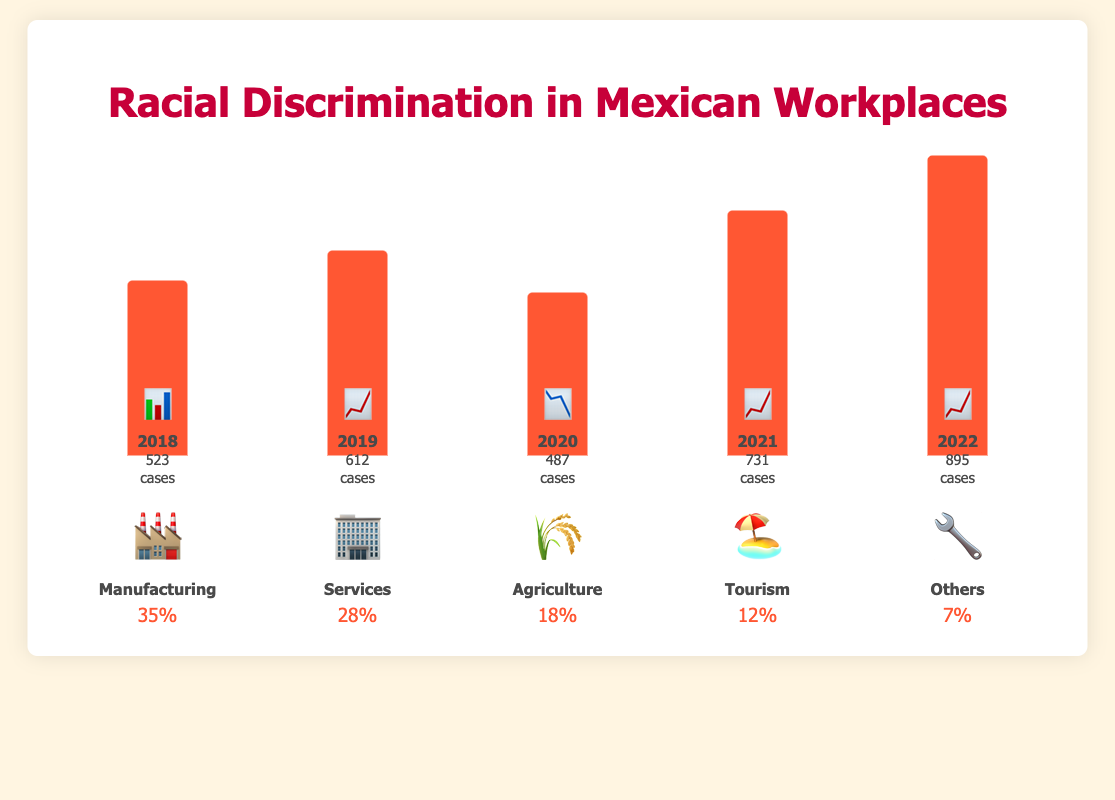How many cases of racial discrimination were reported in Mexican workplaces in 2020? The bar for 2020 shows "487 cases" as per the figure.
Answer: 487 Which year had the highest number of reported cases of racial discrimination? The bar with the greatest height is for the year 2022, marked with "895 cases."
Answer: 2022 What percentage of reported cases come from the Agriculture sector? The Agriculture sector is represented by the emoji 🌾 and has a percentage of "18%" as per the sectors section.
Answer: 18% Compare the number of cases in 2018 to 2019. Did the cases increase or decrease? In 2018, there were 523 cases, and in 2019, there were 612 cases. Since 612 > 523, the cases increased.
Answer: Increased What is the combined percentage of reported cases in the Manufacturing and Services sectors? The percentage for Manufacturing is 35% and for Services, it is 28%. Therefore, 35% + 28% = 63%.
Answer: 63% Which sector has the lowest percentage of reported cases? The "Others" sector, represented by the emoji 🔧, has the smallest percentage of 7%.
Answer: Others By how many cases did reported discrimination increase from 2021 to 2022? The figure shows 731 cases in 2021 and 895 cases in 2022. The difference is 895 - 731 = 164.
Answer: 164 Rank the years from the lowest to the highest reported cases of racial discrimination. The numbers for each year in ascending order are 2020 (487), 2018 (523), 2019 (612), 2021 (731), 2022 (895).
Answer: 2020, 2018, 2019, 2021, 2022 What's the total number of reported cases for the period from 2018 to 2022? Adding the number of cases for each year: 523 + 612 + 487 + 731 + 895 = 3248.
Answer: 3248 Which year saw a decrease in the reported cases compared to the previous year, and by how much? Comparing the years: 2019 (612) to 2020 (487). The decrease is 612 - 487 = 125.
Answer: 2020, by 125 